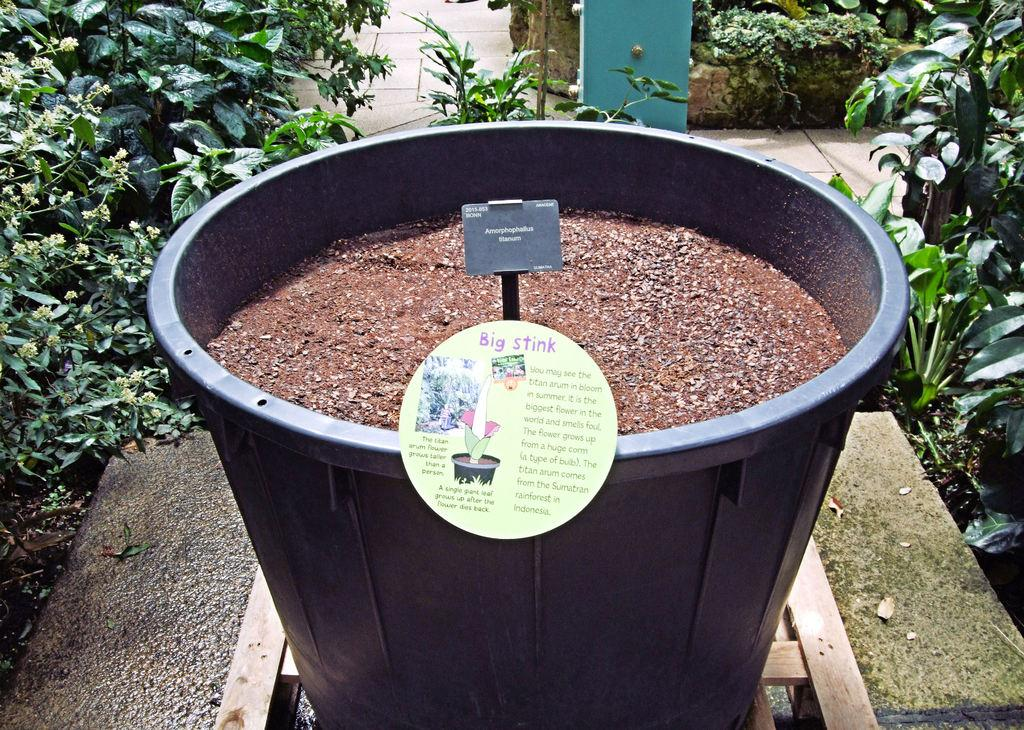What type of living organisms can be seen in the image? Plants can be seen in the image. What else is present in the image besides plants? There are cards with writing and a bucket with mud in the image. Can you describe the cards with writing? Unfortunately, the facts provided do not specify the content or appearance of the cards with writing. What other unspecified objects are present in the image? The facts provided mention that there are other unspecified objects in the image, but their nature is not described. What color is the queen's eye in the image? There is no queen or eye present in the image; it features plants, cards with writing, and a bucket with mud. 